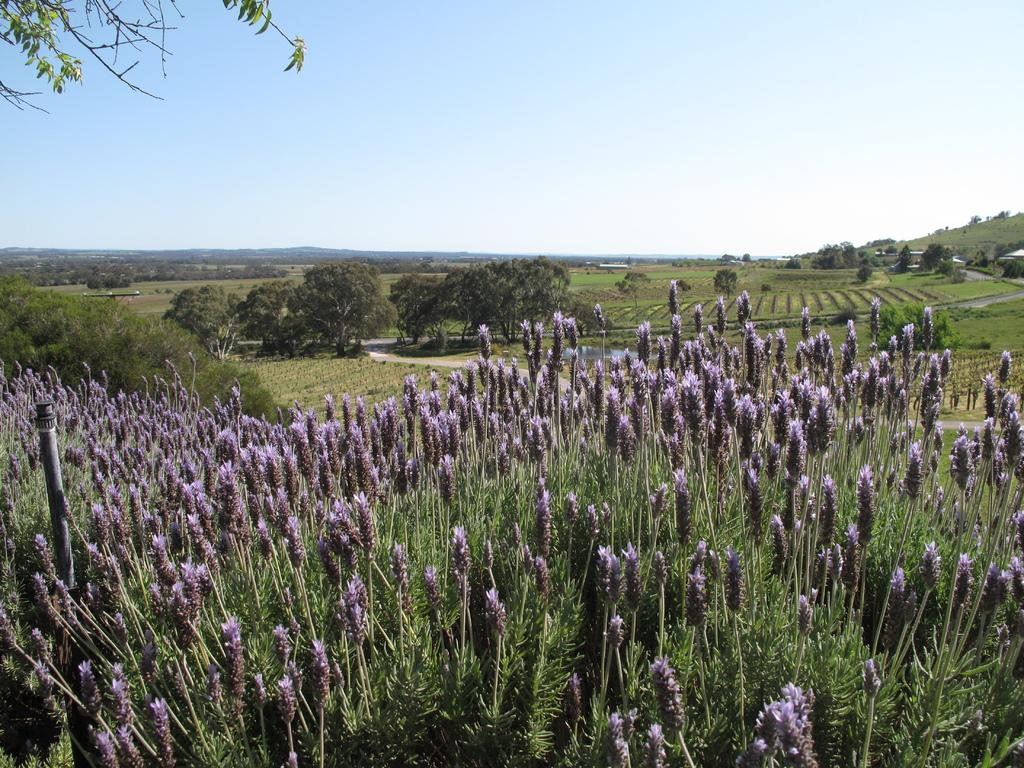What type of vegetation can be seen in the image? There are plants and trees visible in the image. What type of ground cover is present in the image? There is grass visible in the image. What else can be found on the ground in the image? There are other objects on the ground in the image. What can be seen in the background of the image? The sky is visible in the background of the image. How many people are in the crowd in the image? There is no crowd present in the image; it features plants, trees, grass, and other objects on the ground. What type of writing can be seen on the plants in the image? There is no writing present on the plants in the image; they are natural vegetation. 